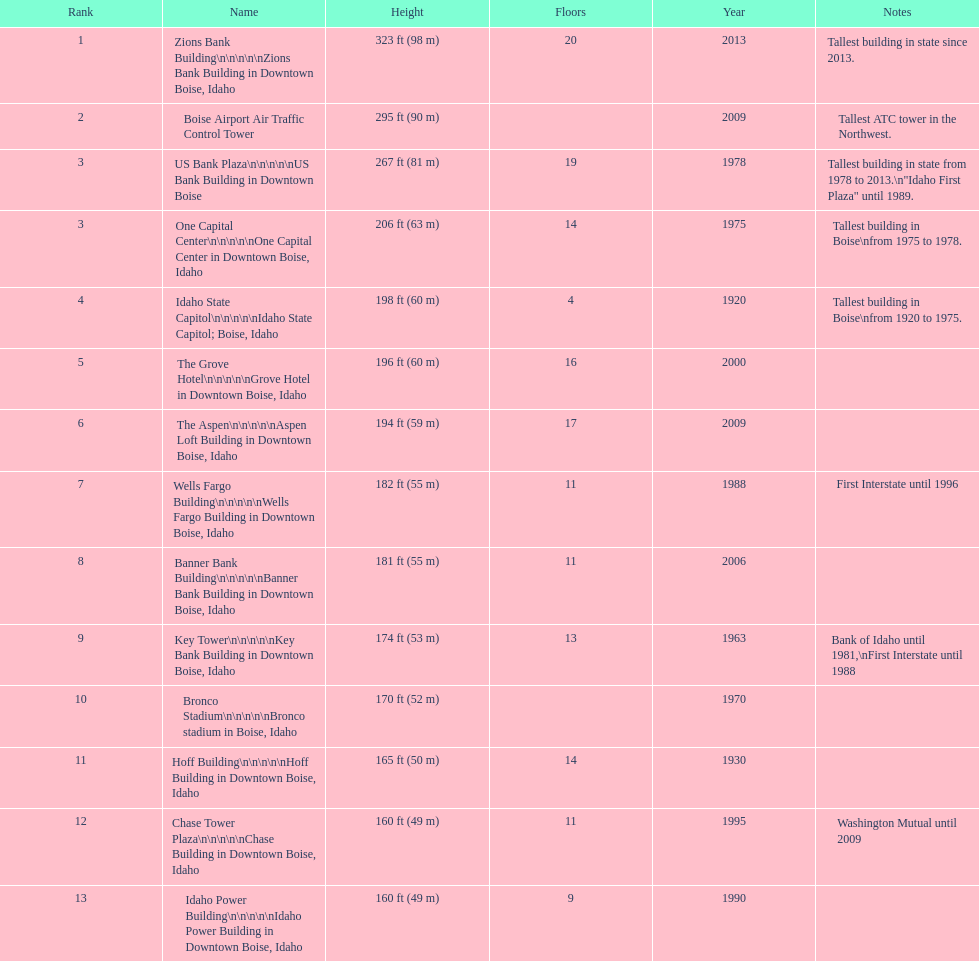In boise, idaho, which structure has the greatest height? Zions Bank Building Zions Bank Building in Downtown Boise, Idaho. 